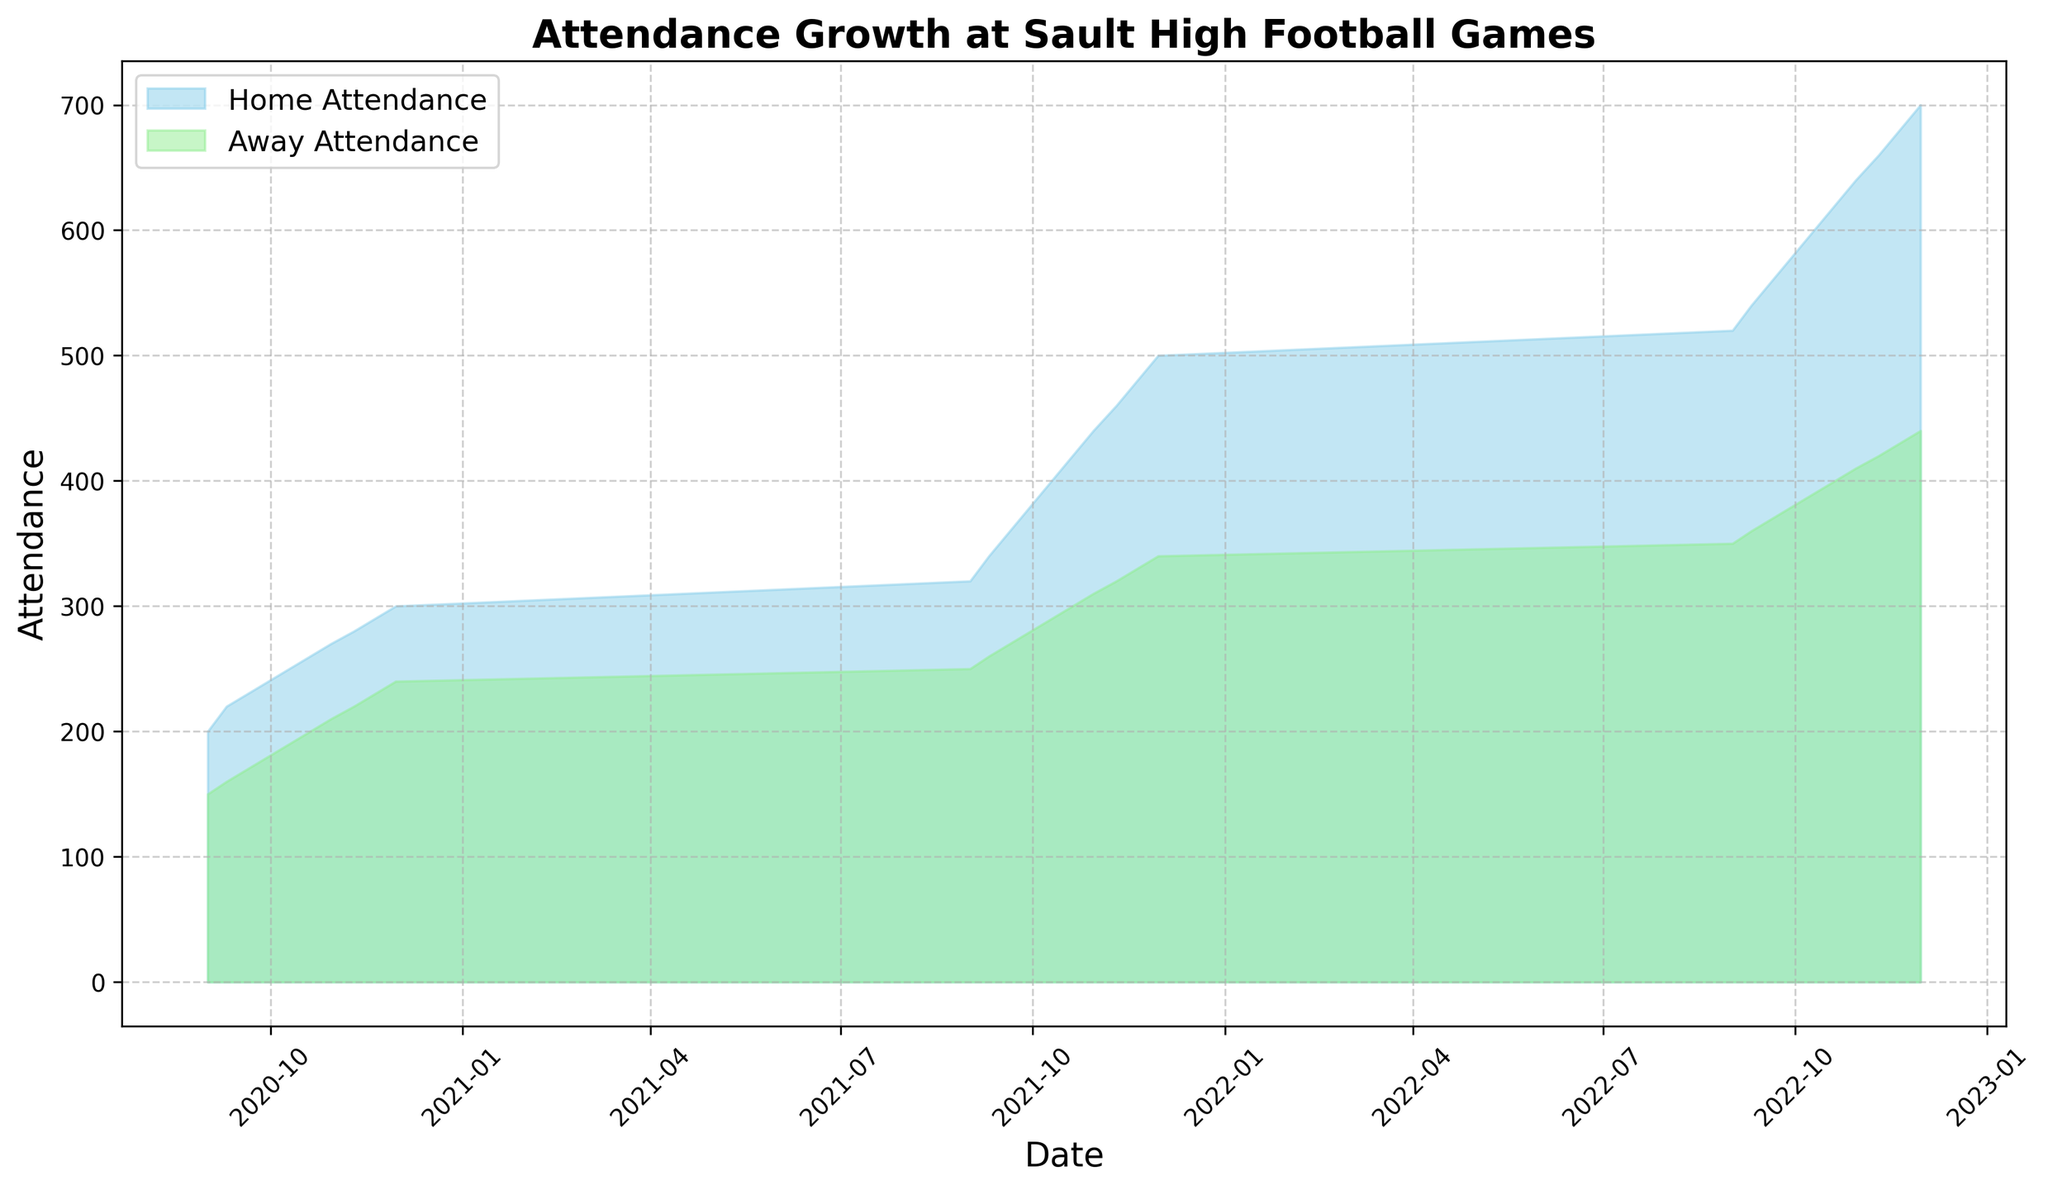How did the attendance for home games change from the beginning to the end of 2021? To find the change in home game attendance during 2021, we look at the home attendance at the beginning of 2021 (320 on September 1) and at the end of 2021 (500 on November 30). The change is calculated as 500 - 320.
Answer: 180 In which period did away games attendance see the steepest rise? To find the steepest rise, we need to look at the segments where the away attendance had the highest increase between dates. The steepest rise seems to occur from September to November 2021, where it goes from 250 to 340.
Answer: September to November 2021 Which month of 2021 saw the highest attendance for home games? Checking the peak attendance for home games in 2021, November had the highest attendance, reaching 500 on November 30.
Answer: November 2021 Compare the growth rate of attendance between home and away games in 2022. To compare growth rates, we examine why home attendance grows from 520 to 700 and away attendance grows from 350 to 440. The growth for home games is 700 - 520 = 180, and for away games is 440 - 350 = 90. Hence, home games had a higher growth rate.
Answer: Home games had a higher growth rate What is the average attendance for away games in 2020? The away attendance numbers in 2020 are (150, 160, 170, 180, 190, 200, 210, 220, 230, 240). Summing these gives 2150, and with 10 data points, the average is 2150 / 10
Answer: 215 During which year did the home attendance first exceed 400? Checking the dates and home attendance values exceeding 400, we see the first instance on October 10, 2021.
Answer: 2021 How much higher was the home attendance compared to away attendance on November 30, 2022? Look at the difference between home (700) and away (440) attendance on November 30, 2022. This gives 700 - 440.
Answer: 260 What can be inferred about the general trend of attendance for both home and away games over this period? Observing the chart, both home and away attendances exhibit a generally increasing trend over the period from September 2020 to November 2022.
Answer: Increasing trend 